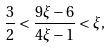Convert formula to latex. <formula><loc_0><loc_0><loc_500><loc_500>\frac { 3 } { 2 } < \frac { 9 \xi - 6 } { 4 \xi - 1 } < \xi ,</formula> 